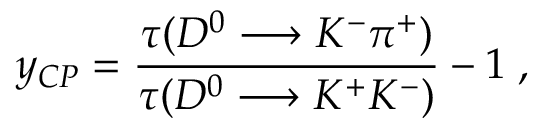Convert formula to latex. <formula><loc_0><loc_0><loc_500><loc_500>y _ { C P } = \frac { \tau ( D ^ { 0 } \longrightarrow K ^ { - } \pi ^ { + } ) } { \tau ( D ^ { 0 } \longrightarrow K ^ { + } K ^ { - } ) } - 1 \, ,</formula> 